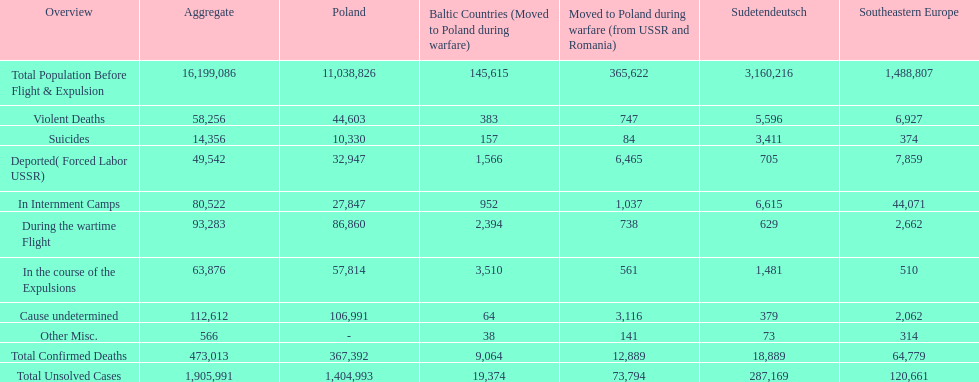Can you give me this table as a dict? {'header': ['Overview', 'Aggregate', 'Poland', 'Baltic Countries (Moved to Poland during warfare)', 'Moved to Poland during warfare (from USSR and Romania)', 'Sudetendeutsch', 'Southeastern Europe'], 'rows': [['Total Population Before Flight & Expulsion', '16,199,086', '11,038,826', '145,615', '365,622', '3,160,216', '1,488,807'], ['Violent Deaths', '58,256', '44,603', '383', '747', '5,596', '6,927'], ['Suicides', '14,356', '10,330', '157', '84', '3,411', '374'], ['Deported( Forced Labor USSR)', '49,542', '32,947', '1,566', '6,465', '705', '7,859'], ['In Internment Camps', '80,522', '27,847', '952', '1,037', '6,615', '44,071'], ['During the wartime Flight', '93,283', '86,860', '2,394', '738', '629', '2,662'], ['In the course of the Expulsions', '63,876', '57,814', '3,510', '561', '1,481', '510'], ['Cause undetermined', '112,612', '106,991', '64', '3,116', '379', '2,062'], ['Other Misc.', '566', '-', '38', '141', '73', '314'], ['Total Confirmed Deaths', '473,013', '367,392', '9,064', '12,889', '18,889', '64,779'], ['Total Unsolved Cases', '1,905,991', '1,404,993', '19,374', '73,794', '287,169', '120,661']]} Was there a larger total population before expulsion in poland or sudetendeutsch? Poland. 